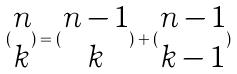Convert formula to latex. <formula><loc_0><loc_0><loc_500><loc_500>( \begin{matrix} n \\ k \end{matrix} ) = ( \begin{matrix} n - 1 \\ k \end{matrix} ) + ( \begin{matrix} n - 1 \\ k - 1 \end{matrix} )</formula> 